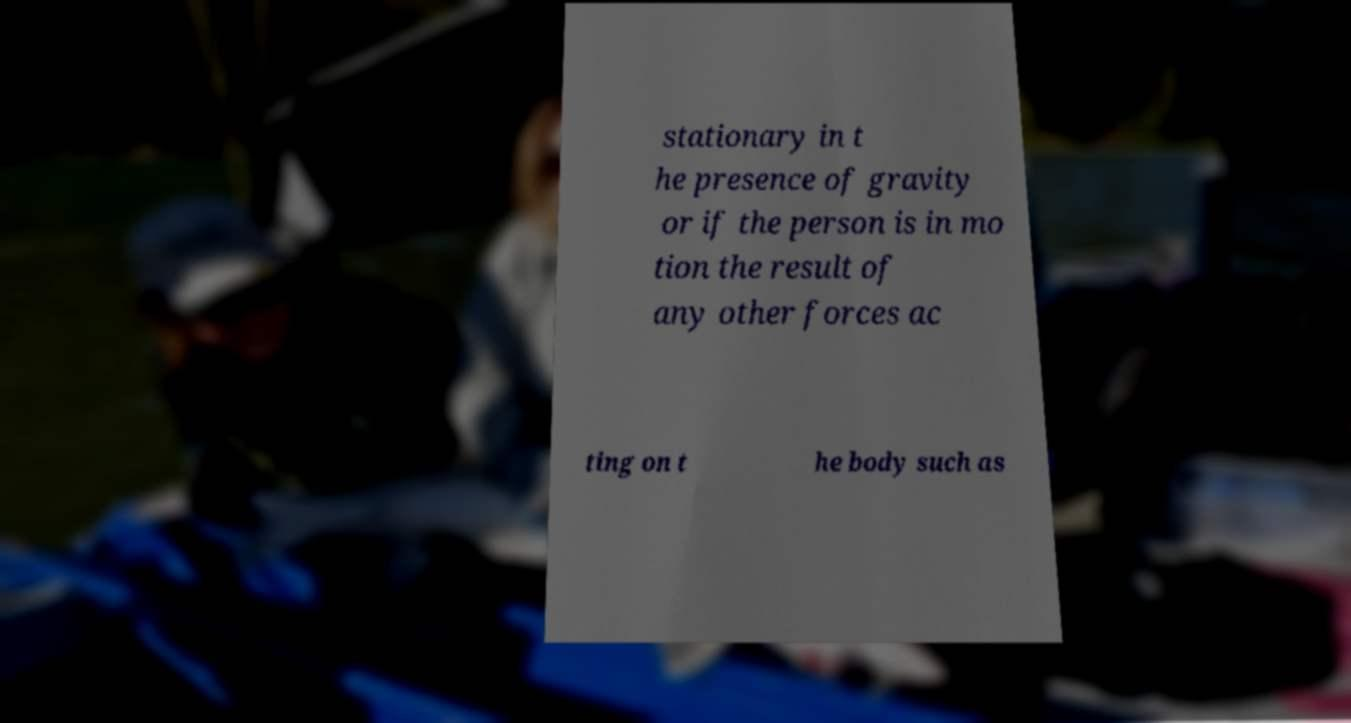Could you assist in decoding the text presented in this image and type it out clearly? stationary in t he presence of gravity or if the person is in mo tion the result of any other forces ac ting on t he body such as 